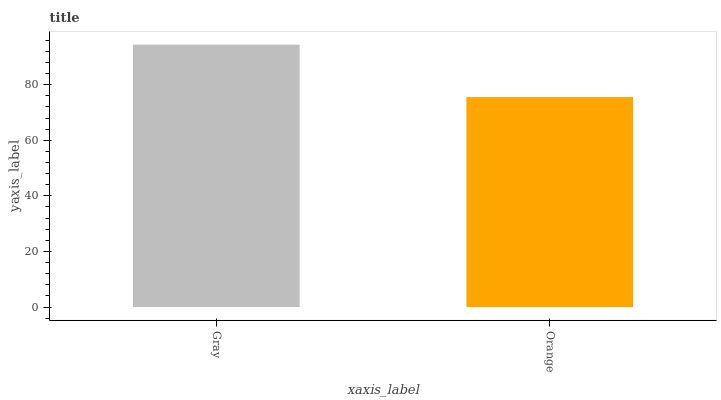Is Orange the minimum?
Answer yes or no. Yes. Is Gray the maximum?
Answer yes or no. Yes. Is Orange the maximum?
Answer yes or no. No. Is Gray greater than Orange?
Answer yes or no. Yes. Is Orange less than Gray?
Answer yes or no. Yes. Is Orange greater than Gray?
Answer yes or no. No. Is Gray less than Orange?
Answer yes or no. No. Is Gray the high median?
Answer yes or no. Yes. Is Orange the low median?
Answer yes or no. Yes. Is Orange the high median?
Answer yes or no. No. Is Gray the low median?
Answer yes or no. No. 